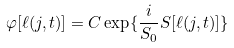<formula> <loc_0><loc_0><loc_500><loc_500>\varphi [ \ell ( j , t ) ] = C \exp \{ \frac { i } { S _ { 0 } } S [ \ell ( j , t ) ] \}</formula> 